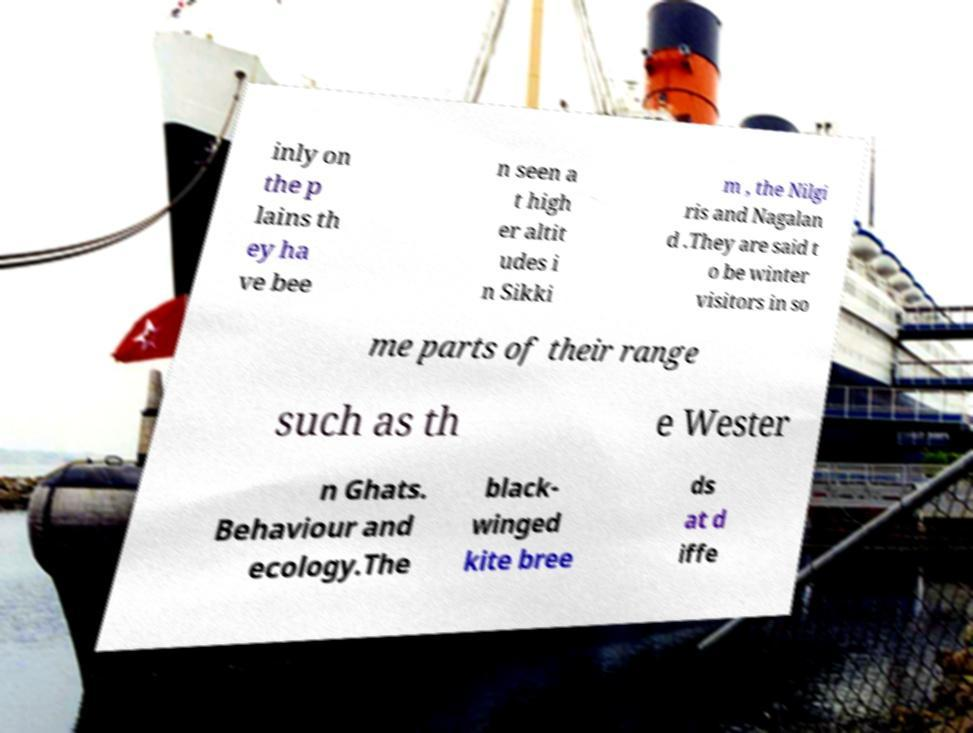I need the written content from this picture converted into text. Can you do that? inly on the p lains th ey ha ve bee n seen a t high er altit udes i n Sikki m , the Nilgi ris and Nagalan d .They are said t o be winter visitors in so me parts of their range such as th e Wester n Ghats. Behaviour and ecology.The black- winged kite bree ds at d iffe 